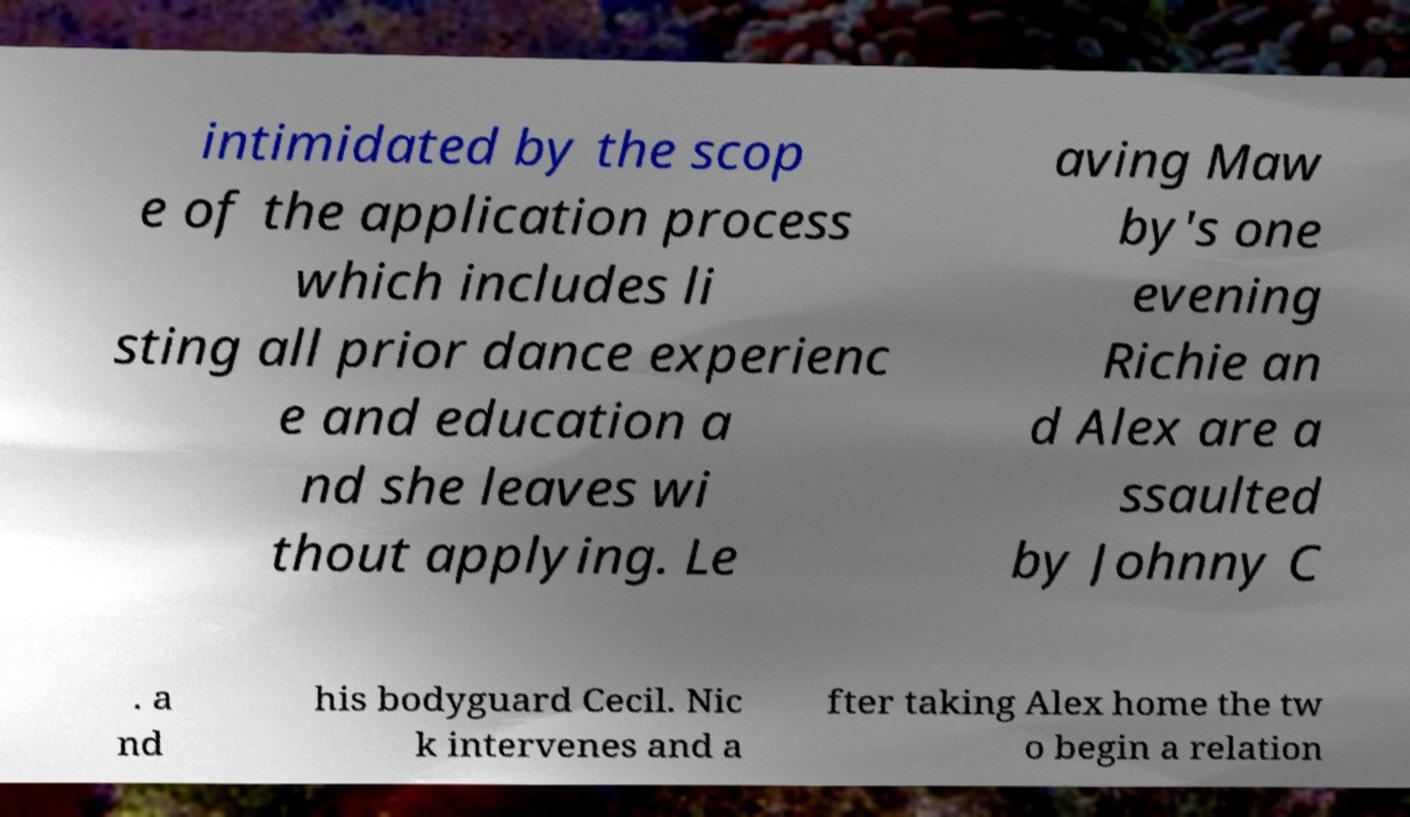For documentation purposes, I need the text within this image transcribed. Could you provide that? intimidated by the scop e of the application process which includes li sting all prior dance experienc e and education a nd she leaves wi thout applying. Le aving Maw by's one evening Richie an d Alex are a ssaulted by Johnny C . a nd his bodyguard Cecil. Nic k intervenes and a fter taking Alex home the tw o begin a relation 